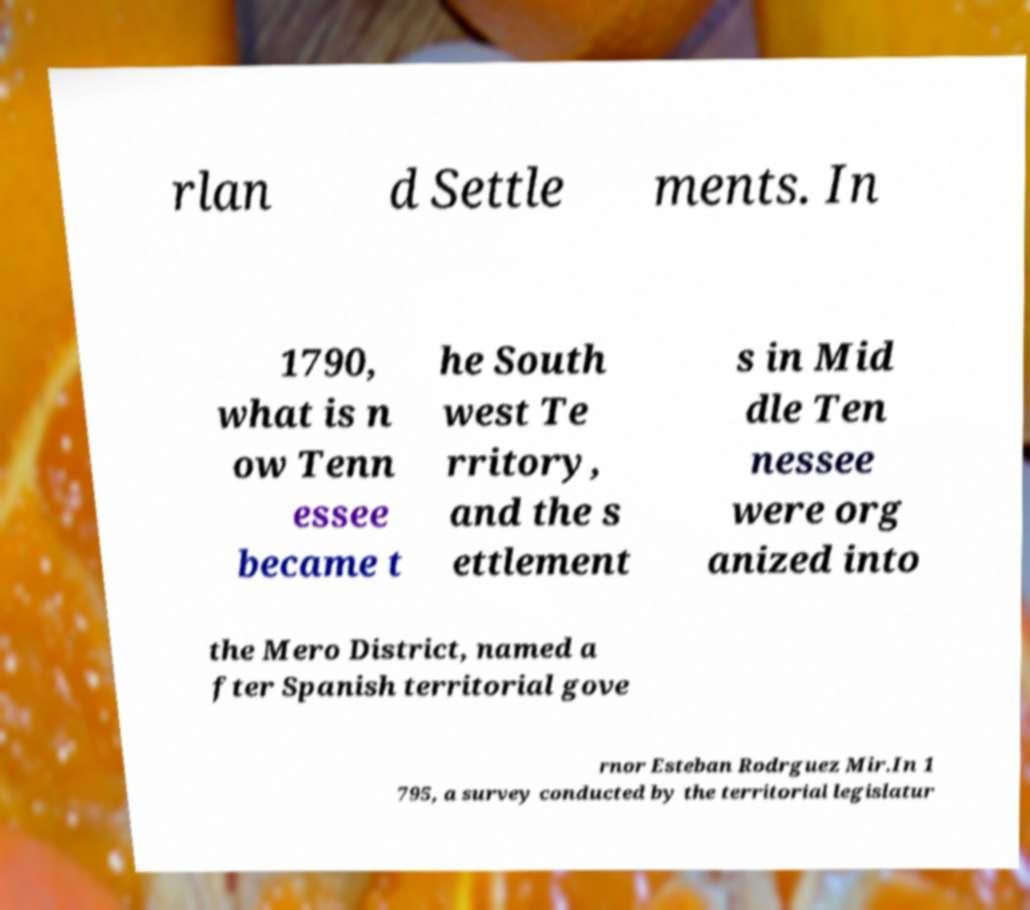For documentation purposes, I need the text within this image transcribed. Could you provide that? rlan d Settle ments. In 1790, what is n ow Tenn essee became t he South west Te rritory, and the s ettlement s in Mid dle Ten nessee were org anized into the Mero District, named a fter Spanish territorial gove rnor Esteban Rodrguez Mir.In 1 795, a survey conducted by the territorial legislatur 